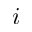Convert formula to latex. <formula><loc_0><loc_0><loc_500><loc_500>i</formula> 